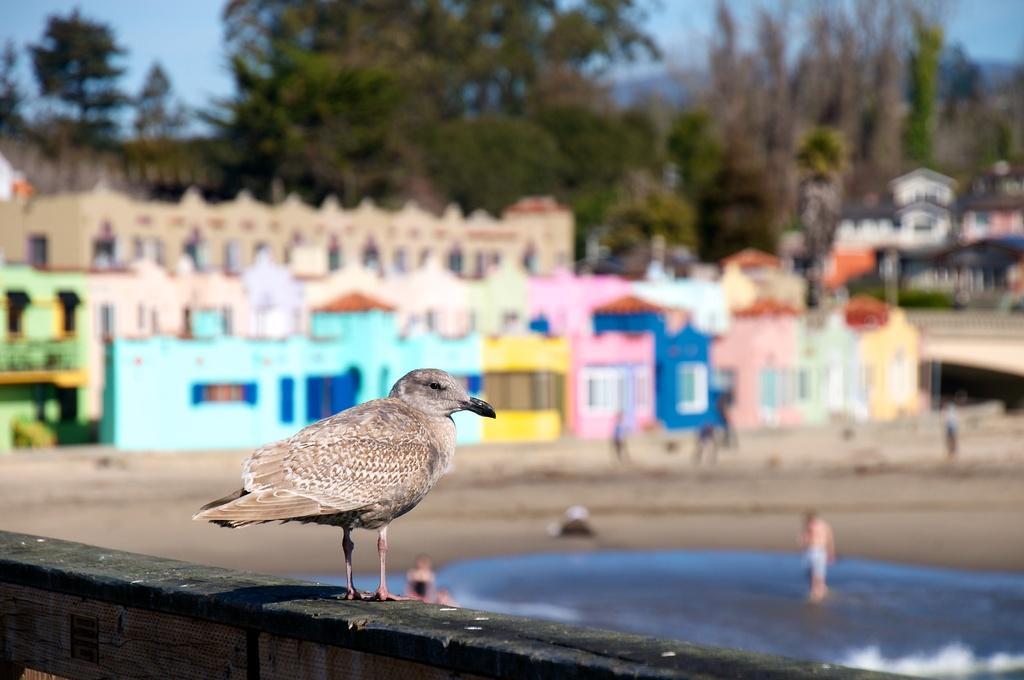In one or two sentences, can you explain what this image depicts? This image is taken outdoors. At the bottom of the image there is a wall and there is a bird on the wall. At the top of the image there is a sky. In the background there are many houses and trees. In the middle of the image there is a pond with water and a few people are standing on the ground. 